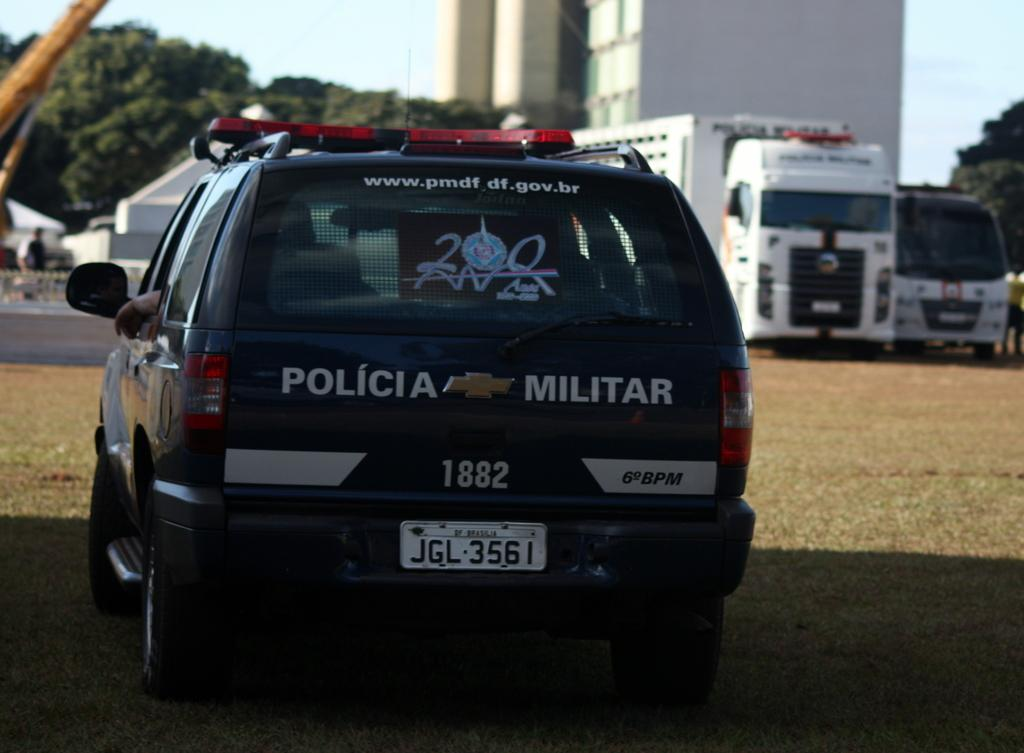What can be seen on the ground in the image? There are vehicles on the ground in the image. What is visible in the background of the image? There are two people, trees, at least one building, some objects, and the sky visible in the background of the image. What type of hospital can be seen in the image? There is no hospital present in the image. What scientific theory is being discussed by the two people in the background? There is no indication of a scientific discussion or theory in the image. 